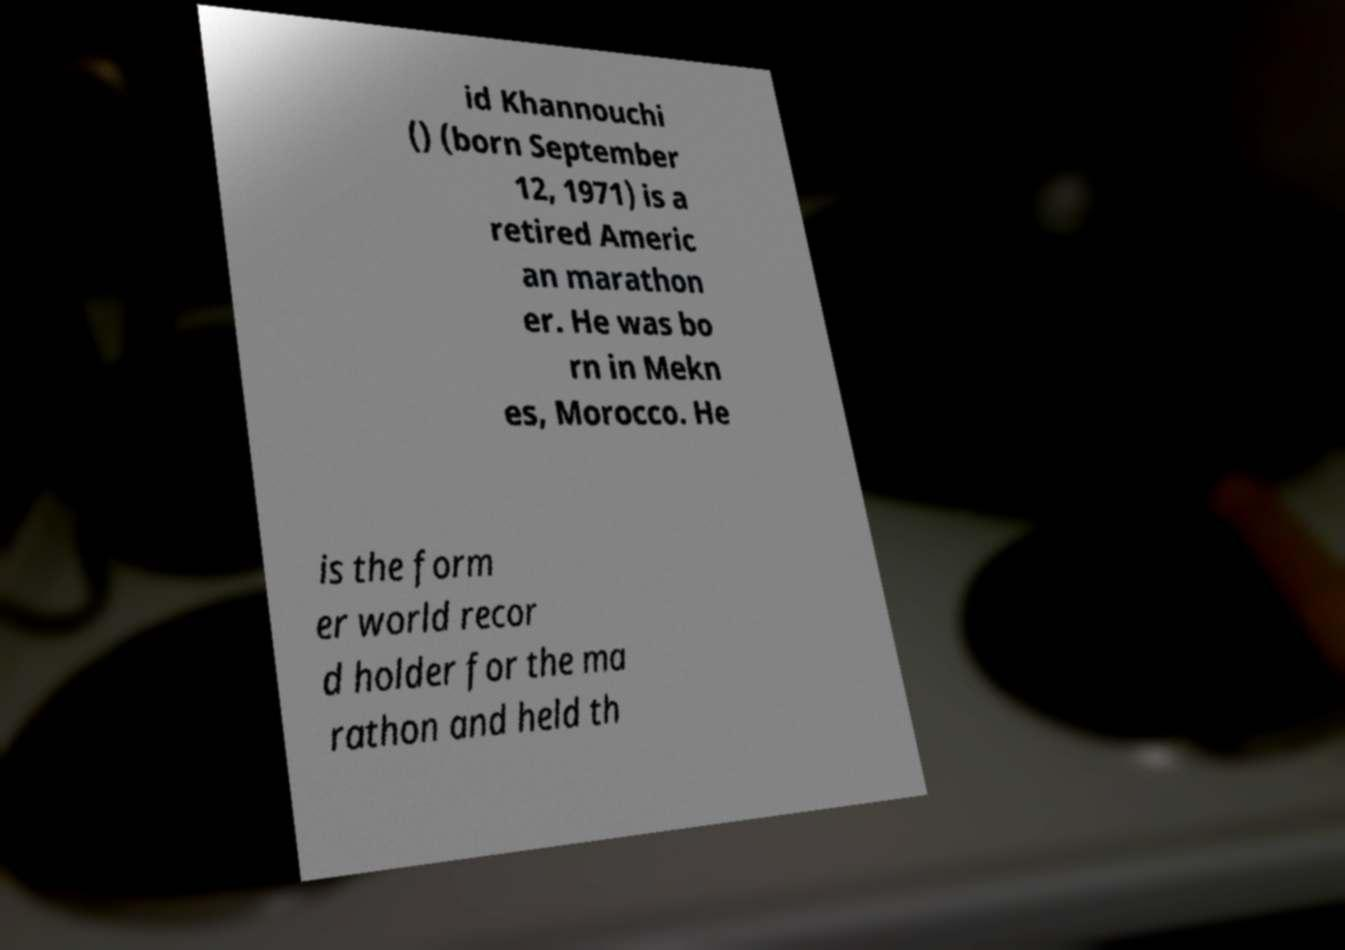Can you read and provide the text displayed in the image?This photo seems to have some interesting text. Can you extract and type it out for me? id Khannouchi () (born September 12, 1971) is a retired Americ an marathon er. He was bo rn in Mekn es, Morocco. He is the form er world recor d holder for the ma rathon and held th 